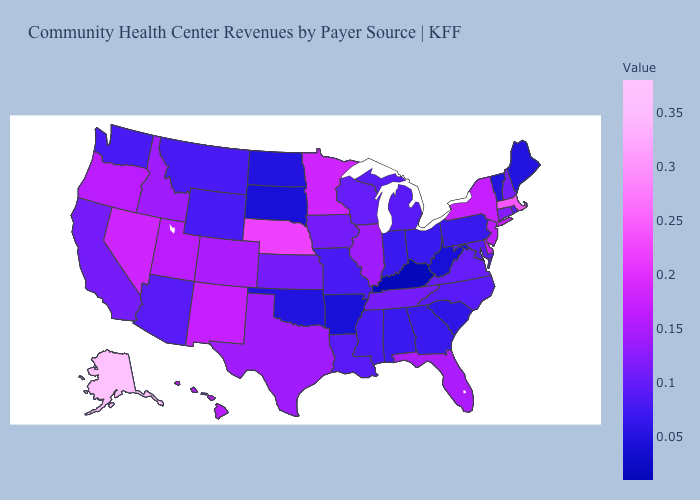Does Alaska have the highest value in the USA?
Keep it brief. Yes. Among the states that border New York , which have the lowest value?
Give a very brief answer. Vermont. Which states hav the highest value in the South?
Short answer required. Delaware. 